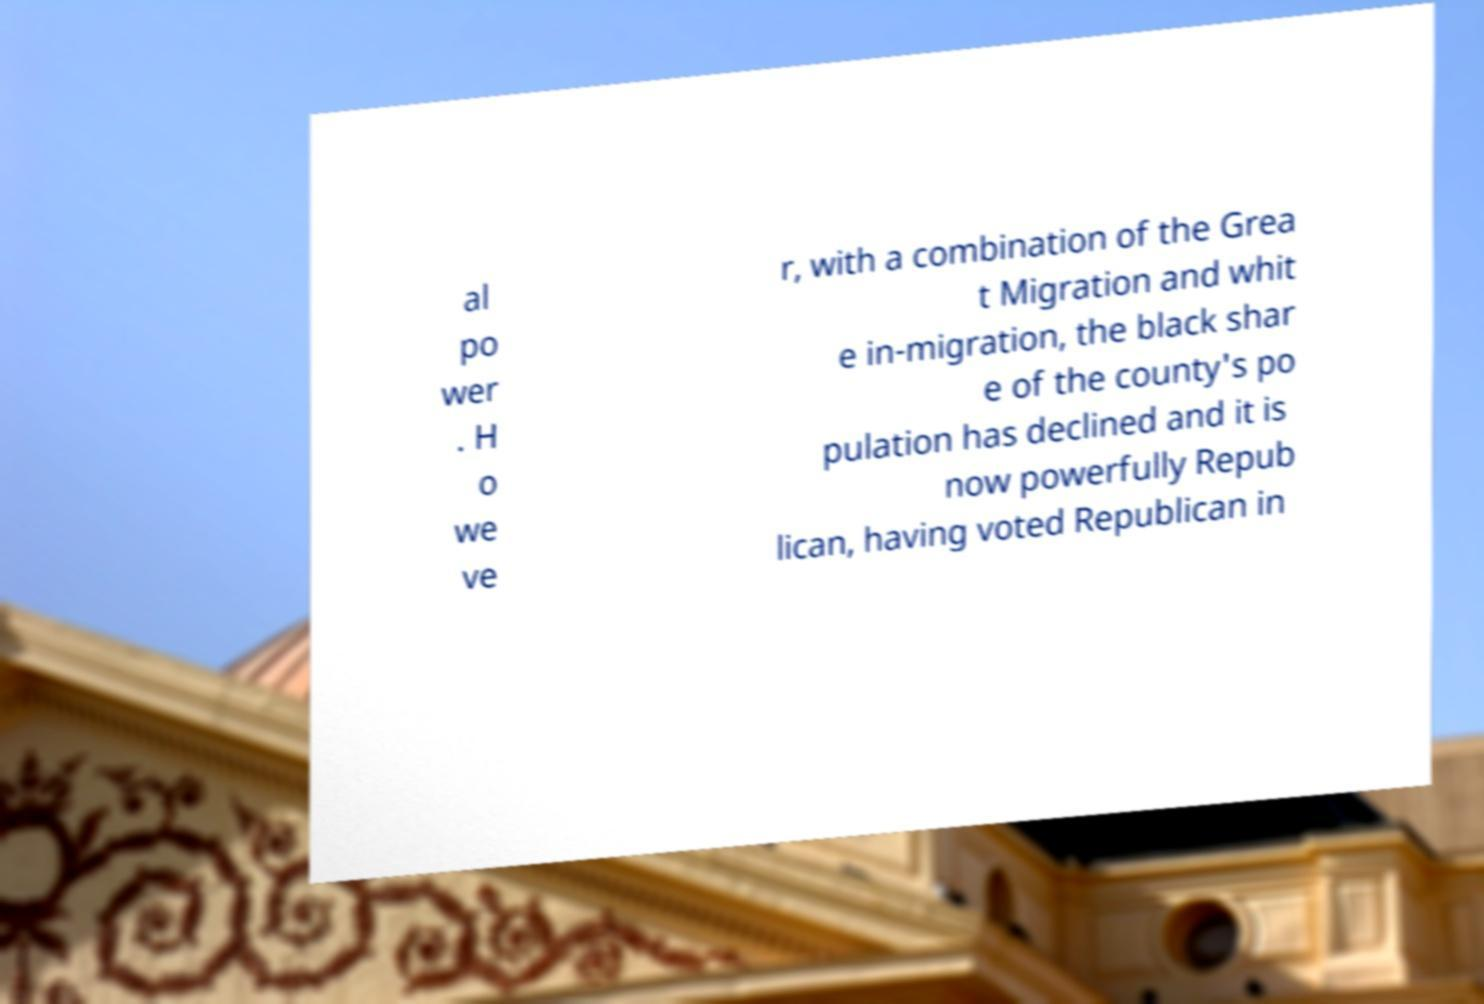Could you assist in decoding the text presented in this image and type it out clearly? al po wer . H o we ve r, with a combination of the Grea t Migration and whit e in-migration, the black shar e of the county's po pulation has declined and it is now powerfully Repub lican, having voted Republican in 